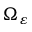<formula> <loc_0><loc_0><loc_500><loc_500>\Omega _ { \varepsilon }</formula> 